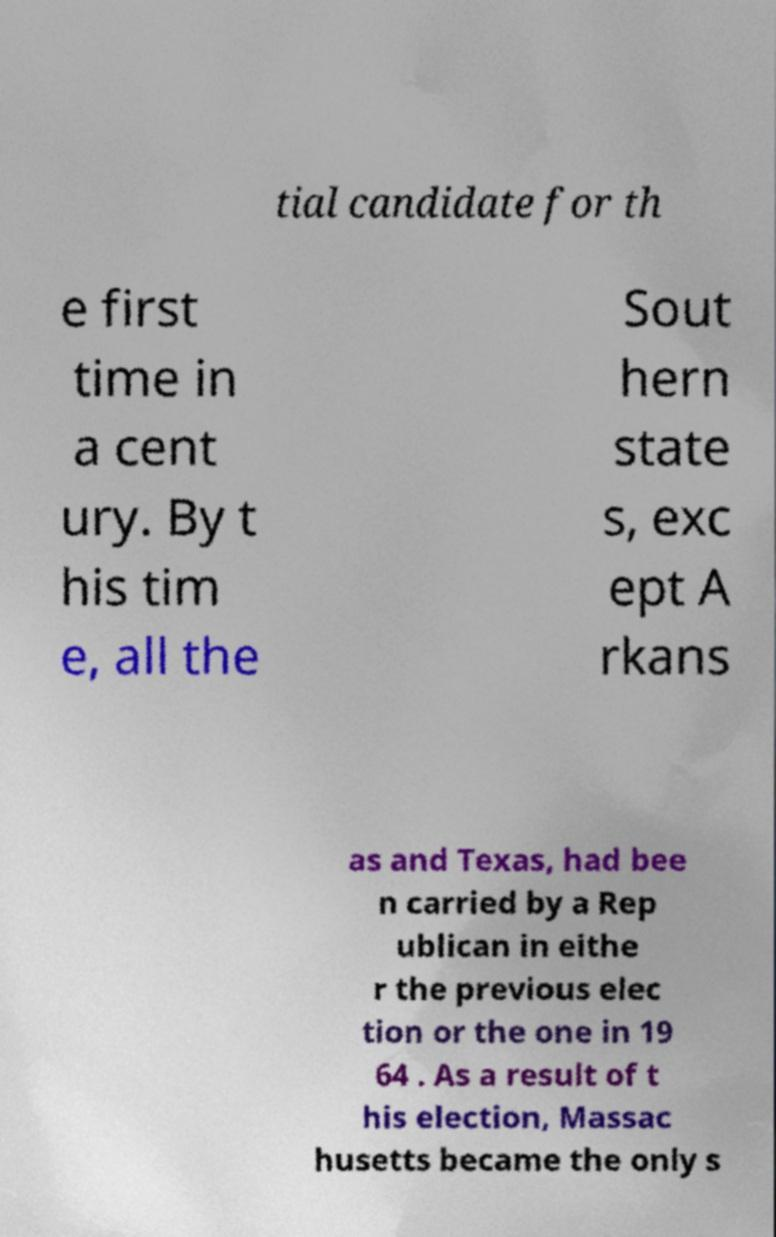I need the written content from this picture converted into text. Can you do that? tial candidate for th e first time in a cent ury. By t his tim e, all the Sout hern state s, exc ept A rkans as and Texas, had bee n carried by a Rep ublican in eithe r the previous elec tion or the one in 19 64 . As a result of t his election, Massac husetts became the only s 